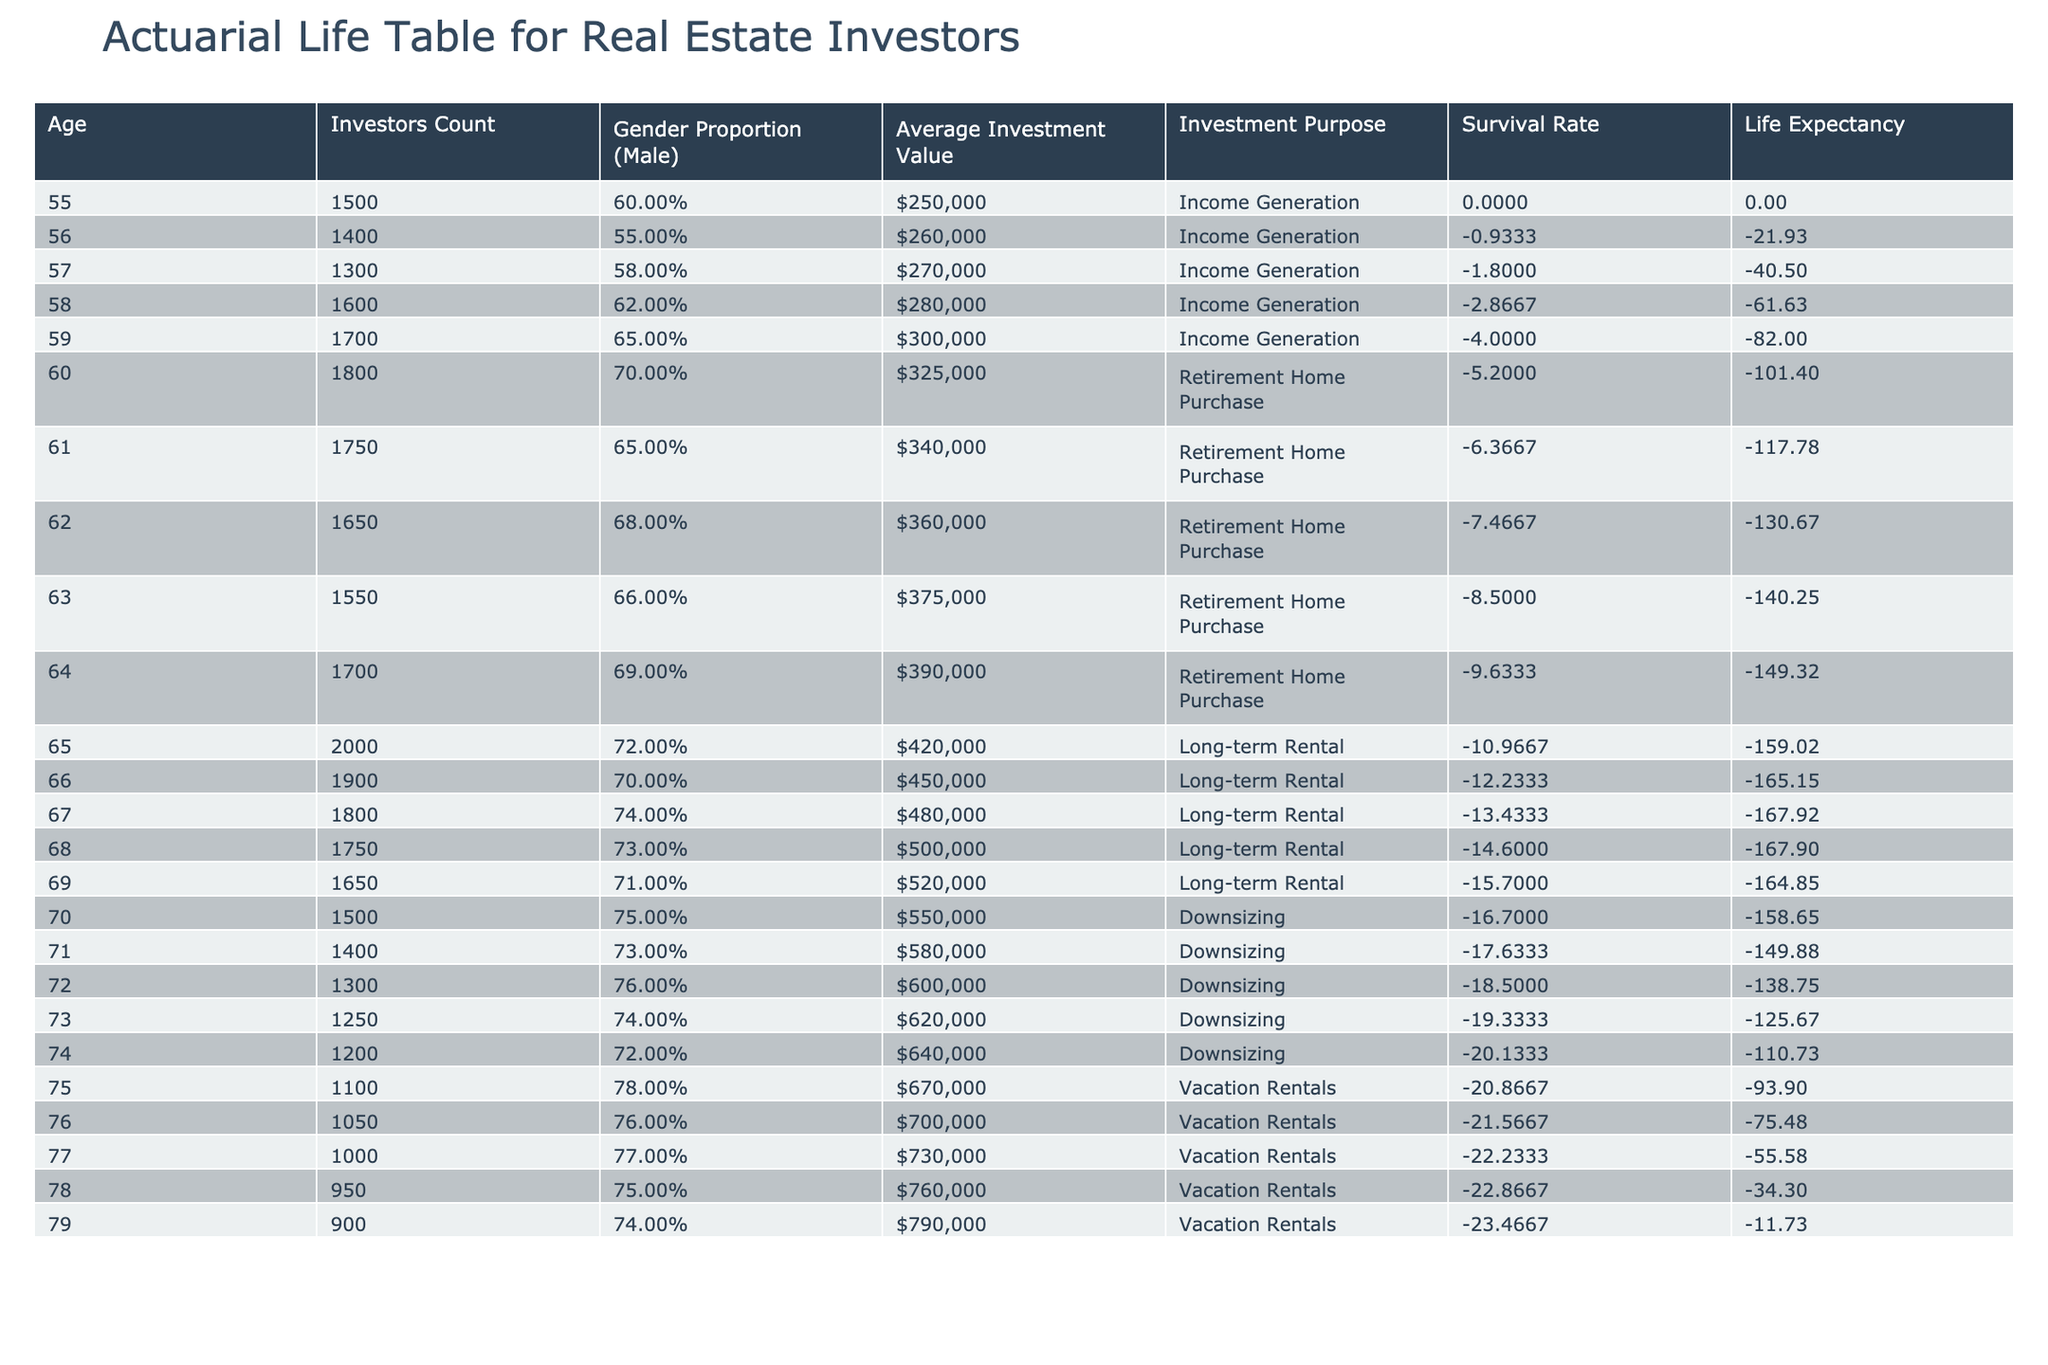What is the investors count for age 65? In the table, the row for age 65 shows the Investors Count as 2000.
Answer: 2000 What is the average investment value for individuals aged 60-64? To find this, we sum the average investment values for ages 60, 61, 62, 63, and 64, which are 325000, 340000, 360000, 375000, and 390000 respectively. The total is 325000 + 340000 + 360000 + 375000 + 390000 = 1790000. There are 5 age values, so the average is 1790000/5 = 358000.
Answer: 358000 What is the gender proportion of investors at age 59? The gender proportion for age 59 is listed as 0.65 in the Gender Proportion column.
Answer: 0.65 Is the average investment value higher for ages 75-79 compared to ages 55-59? First, we calculate the average investment value for ages 75-79, which are 670000, 700000, 730000, 760000, and 790000. The total is 670000 + 700000 + 730000 + 760000 + 790000 = 3650000, and the average is 3650000/5 = 730000. Now for ages 55-59, the average investment values are 250000, 260000, 270000, 280000, and 300000. Their total is 250000 + 260000 + 270000 + 280000 + 300000 = 1360000, resulting in an average of 1360000/5 = 272000. Since 730000 > 272000, the answer is yes.
Answer: Yes What is the total investors count for ages 70-74? To find this, we add the Investors Count for ages 70, 71, 72, 73, and 74, which are 1500, 1400, 1300, 1250, and 1200 respectively. The sum is 1500 + 1400 + 1300 + 1250 + 1200 = 6150.
Answer: 6150 Which investment purpose has the highest average investment value? We systematically compare the average investment values associated with each investment purpose: Income Generation has an average of 272000, Retirement Home Purchase has 364000, Long-term Rental has 488000, Downsizing has 616000, and Vacation Rentals has 749000. Since 749000 (Vacation Rentals) is the highest value, the answer is Vacation Rentals.
Answer: Vacation Rentals Is the survival rate for age 75 higher than that for age 70? According to the table, the survival rate for age 75 is proportional to the Investors Count compared to the first age group. To analyze, we need to compare those values. The Investors Count for age 75 is 1100, which forms a lower cumulative survival count than for age 70, which is 1500. Thus, since 1 - (1100/1500) yields a lower survival rate than the calculation for age 70, the conclusion is no.
Answer: No What is the average gender proportion for the ages 65-69? The gender proportions for ages 65, 66, 67, 68, and 69 are 0.72, 0.70, 0.74, 0.73, and 0.71 respectively. To calculate the average, we sum these proportions: 0.72 + 0.70 + 0.74 + 0.73 + 0.71 = 3.60. The average is then 3.60 / 5 = 0.72.
Answer: 0.72 